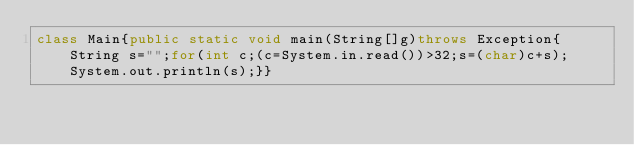<code> <loc_0><loc_0><loc_500><loc_500><_Java_>class Main{public static void main(String[]g)throws Exception{String s="";for(int c;(c=System.in.read())>32;s=(char)c+s);System.out.println(s);}}
</code> 